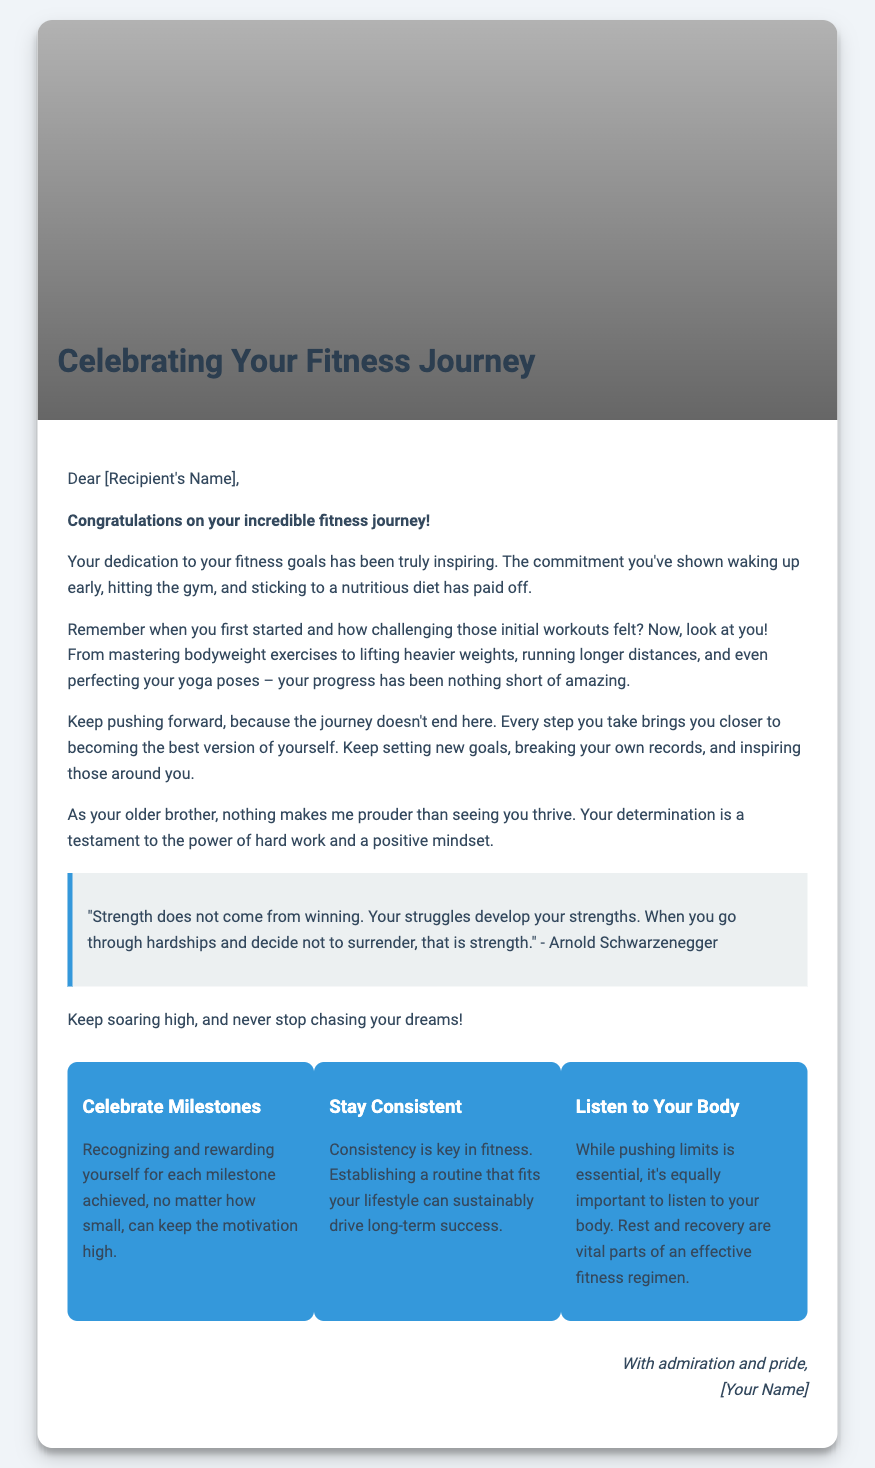What is the title of the card? The title is prominently displayed in the cover section of the document.
Answer: Celebrating Your Fitness Journey Who is the card addressed to? The salutation indicates the recipient's name placeholder in the greeting.
Answer: [Recipient's Name] Which quote is included in the card? The document features an inspirational quote attributed to a well-known figure.
Answer: "Strength does not come from winning. Your struggles develop your strengths..." What are the three tips provided in the card? The tips are listed as distinct sections with headings in the document.
Answer: Celebrate Milestones, Stay Consistent, Listen to Your Body How does the card make the recipient feel? The tone and messages throughout the card aim to evoke emotions related to achievement and motivation.
Answer: Proud What kind of image is used on the cover of the card? The background image is described in the document as related to a specific athletic event.
Answer: Athletic image What is emphasized as vital in a fitness regimen? The content highlights the importance of a specific aspect in fitness.
Answer: Rest and recovery What is the overall theme of the card's message? The document's content is focused on celebrating an achievement in a specific journey.
Answer: Fitness journey Who is the sender of the card? The closing signature indicates the name of the person sending the card.
Answer: [Your Name] 